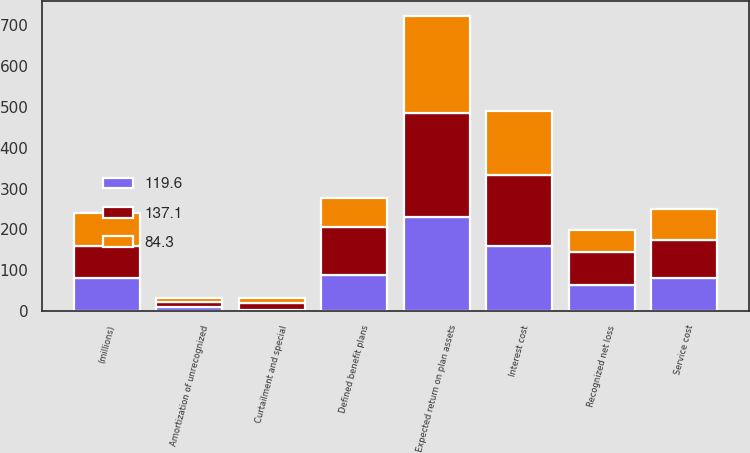<chart> <loc_0><loc_0><loc_500><loc_500><stacked_bar_chart><ecel><fcel>(millions)<fcel>Service cost<fcel>Interest cost<fcel>Expected return on plan assets<fcel>Amortization of unrecognized<fcel>Recognized net loss<fcel>Curtailment and special<fcel>Defined benefit plans<nl><fcel>137.1<fcel>79.8<fcel>94.2<fcel>172<fcel>256.7<fcel>12.4<fcel>79.8<fcel>16.7<fcel>118.4<nl><fcel>119.6<fcel>79.8<fcel>80.2<fcel>160.1<fcel>229<fcel>10<fcel>64.5<fcel>1.6<fcel>87.7<nl><fcel>84.3<fcel>79.8<fcel>76<fcel>157.3<fcel>238.1<fcel>8.2<fcel>54.1<fcel>12.2<fcel>69.9<nl></chart> 